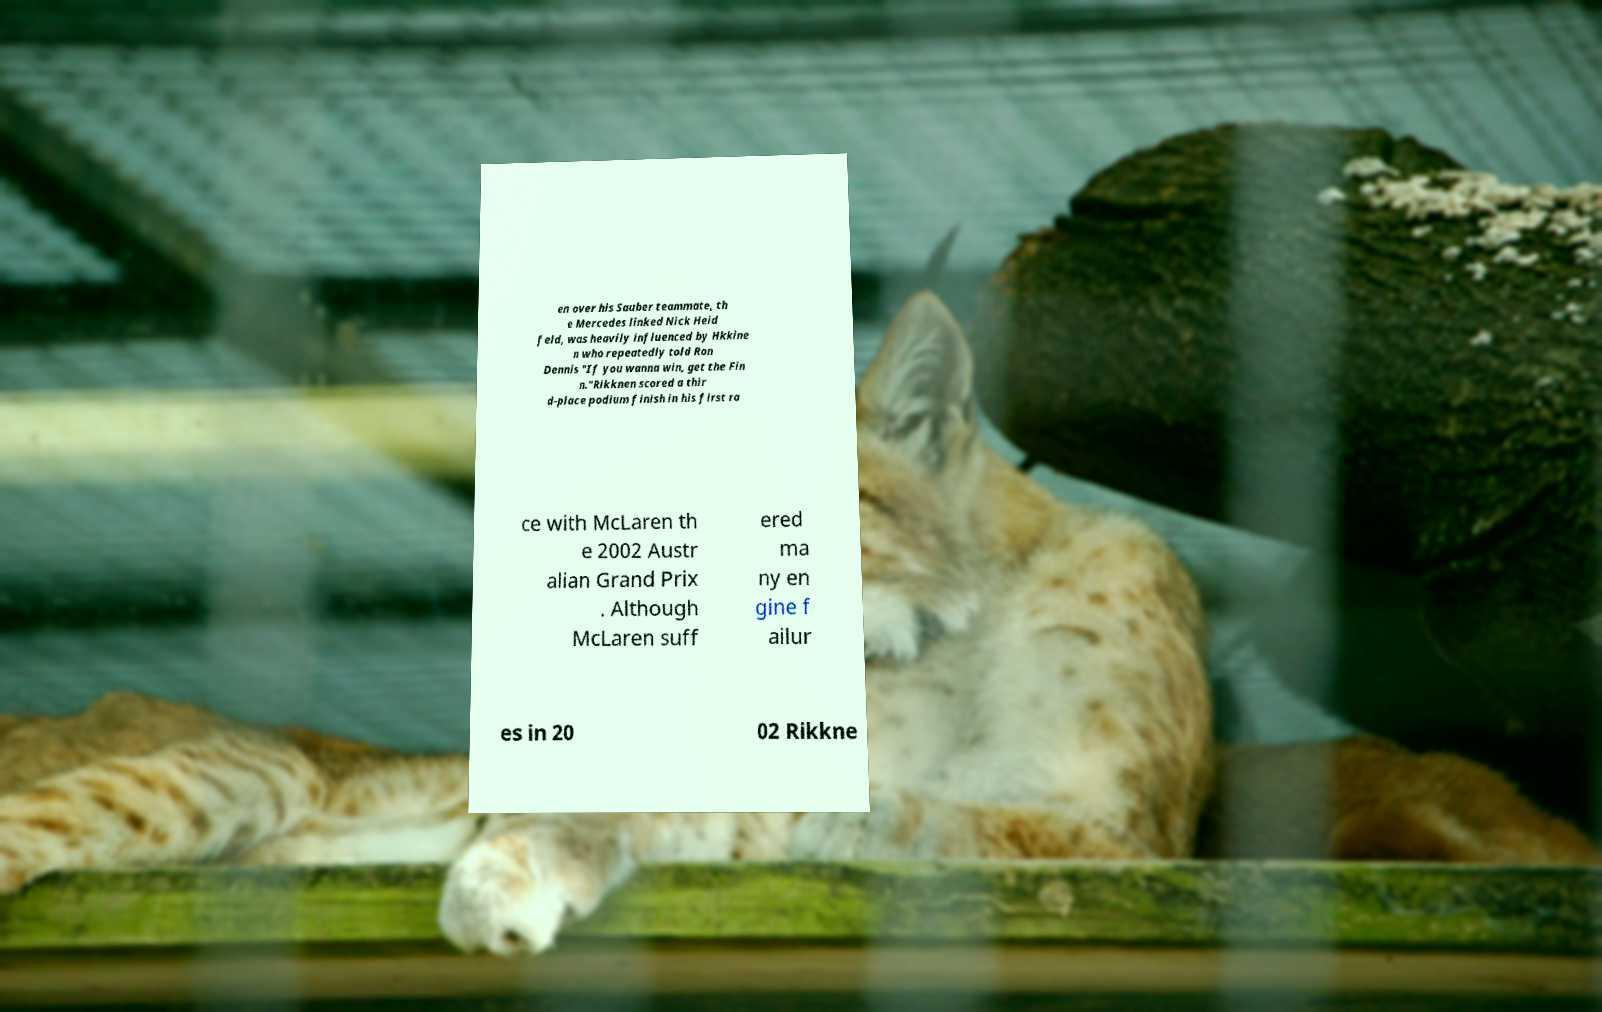Can you accurately transcribe the text from the provided image for me? en over his Sauber teammate, th e Mercedes linked Nick Heid feld, was heavily influenced by Hkkine n who repeatedly told Ron Dennis "If you wanna win, get the Fin n."Rikknen scored a thir d-place podium finish in his first ra ce with McLaren th e 2002 Austr alian Grand Prix . Although McLaren suff ered ma ny en gine f ailur es in 20 02 Rikkne 